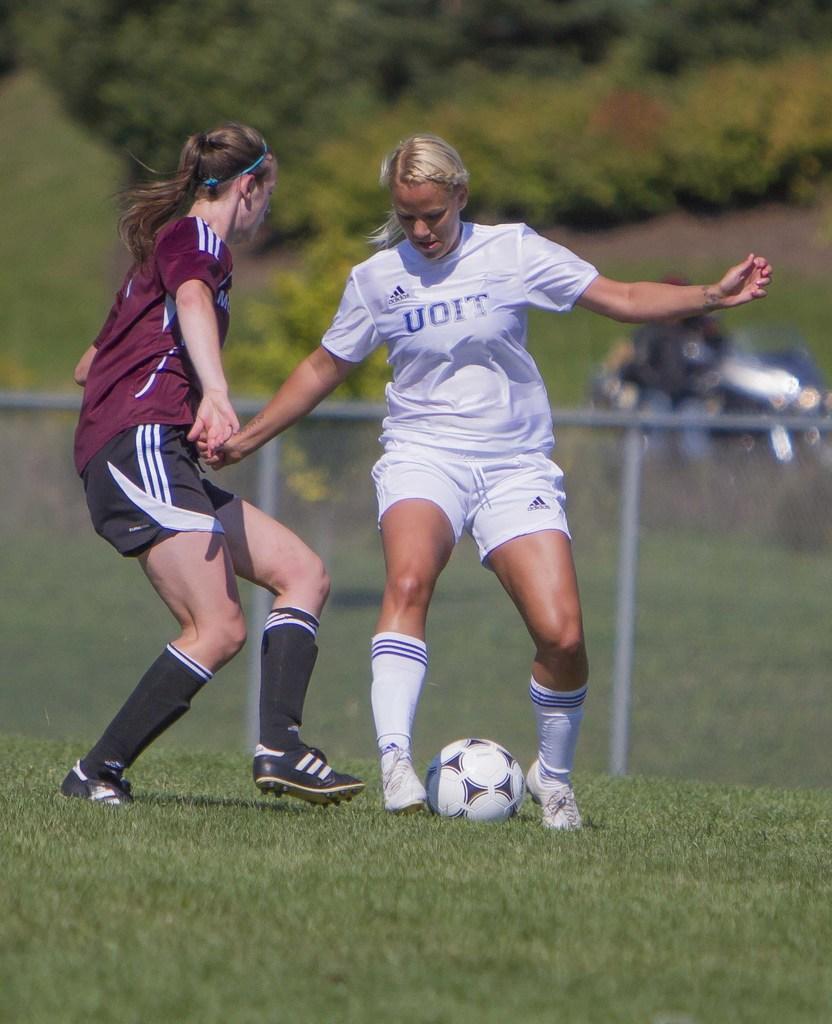How would you summarize this image in a sentence or two? In this image two woman are playing football trying to kick the football on a grassy land. Backside there is a fence. Background of image are having plants. 